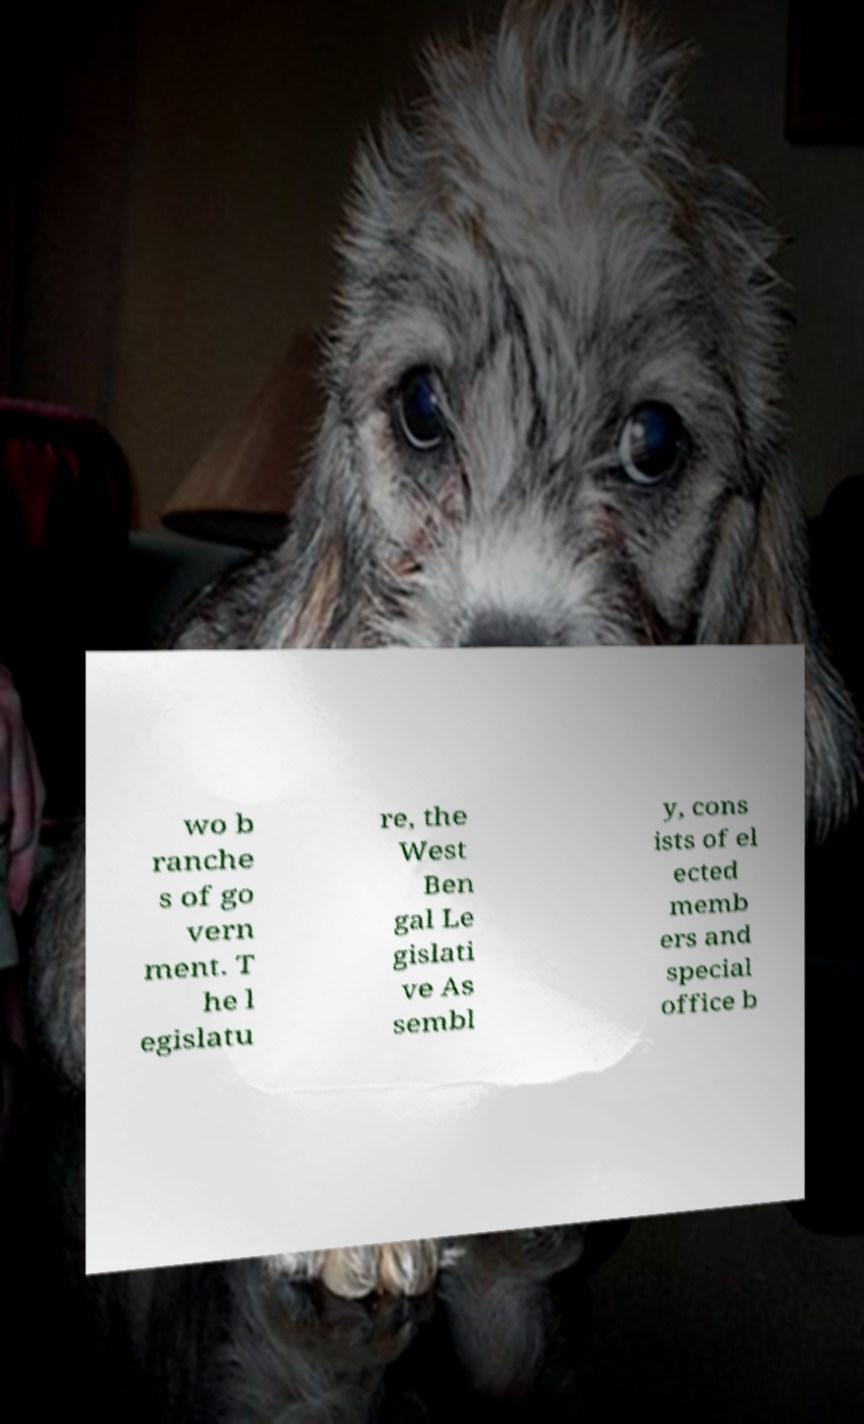Can you read and provide the text displayed in the image?This photo seems to have some interesting text. Can you extract and type it out for me? wo b ranche s of go vern ment. T he l egislatu re, the West Ben gal Le gislati ve As sembl y, cons ists of el ected memb ers and special office b 